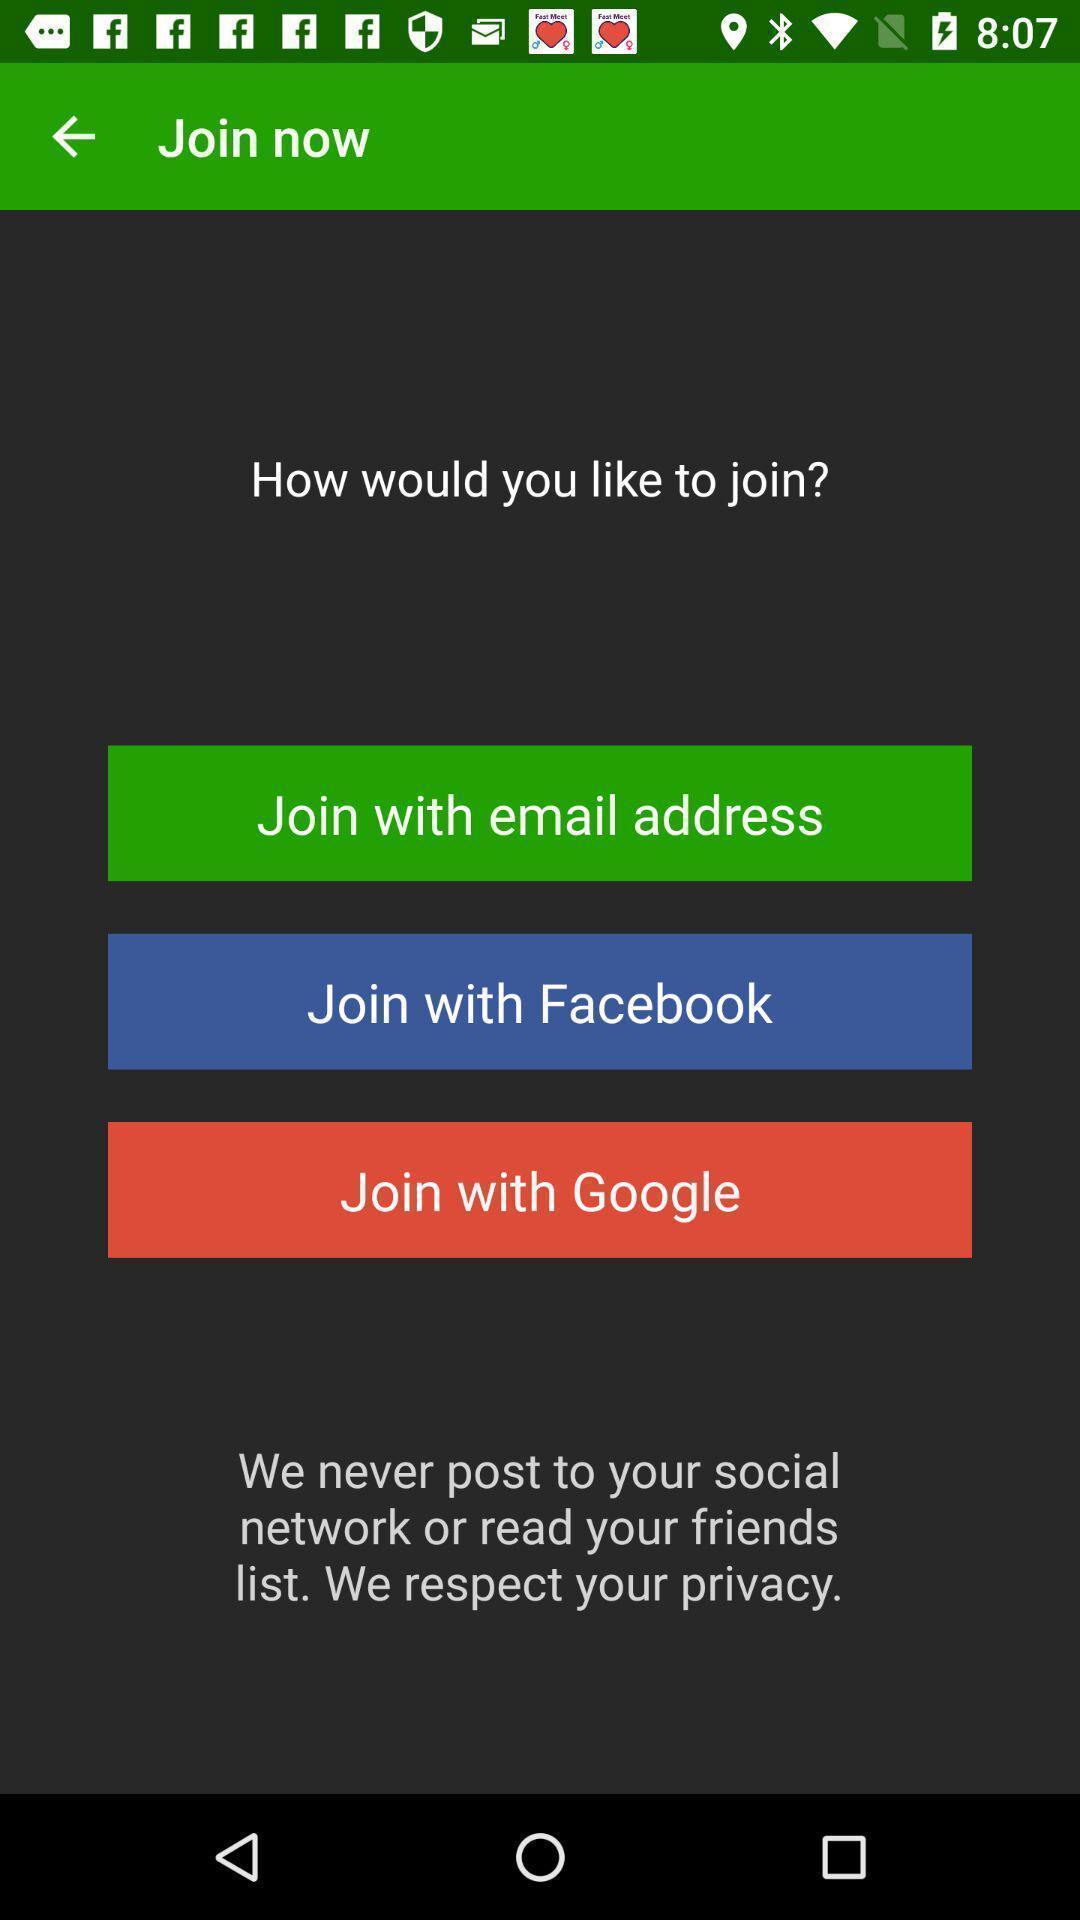What is the overall content of this screenshot? Screen displaying multiple sign in options. 